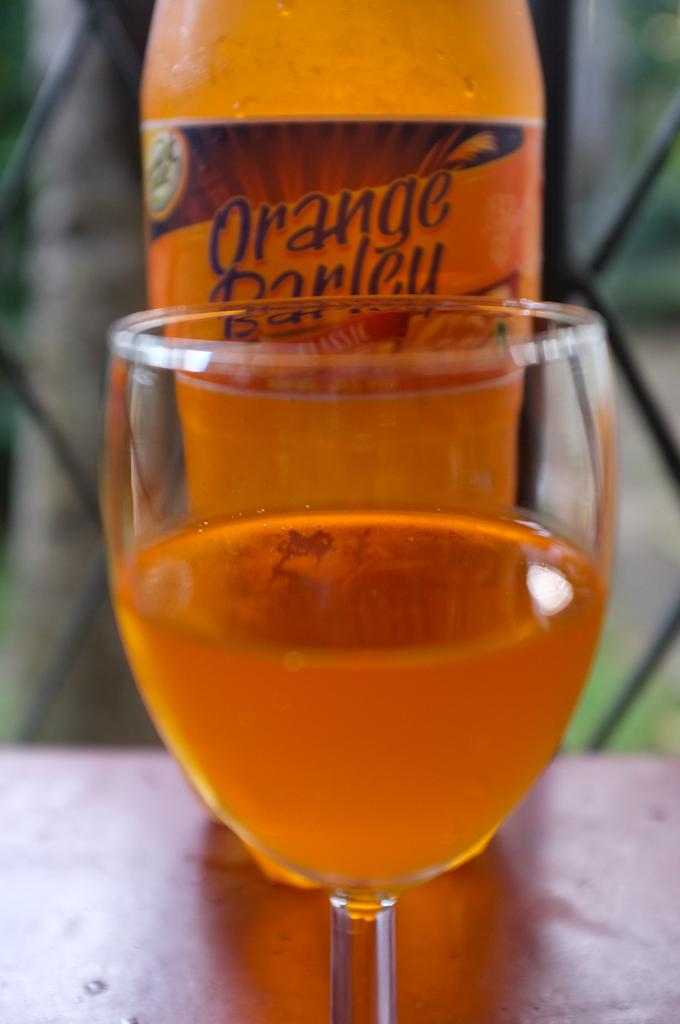<image>
Offer a succinct explanation of the picture presented. Orange Barley bottle next to a cup of orange barley. 